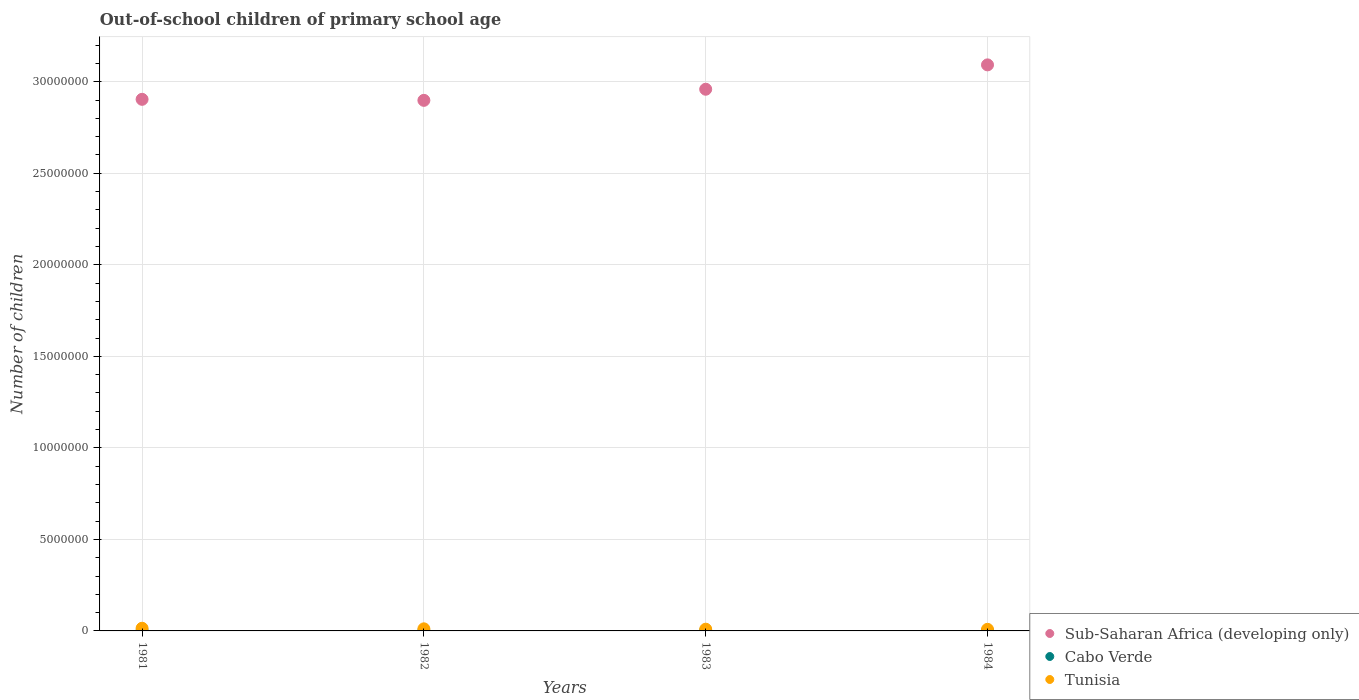How many different coloured dotlines are there?
Give a very brief answer. 3. Is the number of dotlines equal to the number of legend labels?
Ensure brevity in your answer.  Yes. What is the number of out-of-school children in Cabo Verde in 1982?
Offer a terse response. 6291. Across all years, what is the maximum number of out-of-school children in Tunisia?
Make the answer very short. 1.45e+05. Across all years, what is the minimum number of out-of-school children in Sub-Saharan Africa (developing only)?
Your response must be concise. 2.90e+07. In which year was the number of out-of-school children in Sub-Saharan Africa (developing only) minimum?
Provide a succinct answer. 1982. What is the total number of out-of-school children in Cabo Verde in the graph?
Provide a succinct answer. 2.58e+04. What is the difference between the number of out-of-school children in Cabo Verde in 1982 and that in 1984?
Your answer should be compact. 666. What is the difference between the number of out-of-school children in Cabo Verde in 1984 and the number of out-of-school children in Sub-Saharan Africa (developing only) in 1983?
Keep it short and to the point. -2.96e+07. What is the average number of out-of-school children in Sub-Saharan Africa (developing only) per year?
Your answer should be compact. 2.96e+07. In the year 1981, what is the difference between the number of out-of-school children in Sub-Saharan Africa (developing only) and number of out-of-school children in Tunisia?
Offer a very short reply. 2.89e+07. What is the ratio of the number of out-of-school children in Sub-Saharan Africa (developing only) in 1983 to that in 1984?
Your answer should be compact. 0.96. Is the number of out-of-school children in Sub-Saharan Africa (developing only) in 1983 less than that in 1984?
Provide a succinct answer. Yes. Is the difference between the number of out-of-school children in Sub-Saharan Africa (developing only) in 1981 and 1983 greater than the difference between the number of out-of-school children in Tunisia in 1981 and 1983?
Your response must be concise. No. What is the difference between the highest and the second highest number of out-of-school children in Tunisia?
Your response must be concise. 3.15e+04. What is the difference between the highest and the lowest number of out-of-school children in Cabo Verde?
Your response must be concise. 2586. Is the sum of the number of out-of-school children in Tunisia in 1982 and 1983 greater than the maximum number of out-of-school children in Sub-Saharan Africa (developing only) across all years?
Make the answer very short. No. Is it the case that in every year, the sum of the number of out-of-school children in Sub-Saharan Africa (developing only) and number of out-of-school children in Cabo Verde  is greater than the number of out-of-school children in Tunisia?
Keep it short and to the point. Yes. How many dotlines are there?
Your response must be concise. 3. How many years are there in the graph?
Make the answer very short. 4. What is the difference between two consecutive major ticks on the Y-axis?
Ensure brevity in your answer.  5.00e+06. Where does the legend appear in the graph?
Give a very brief answer. Bottom right. How are the legend labels stacked?
Provide a short and direct response. Vertical. What is the title of the graph?
Your answer should be very brief. Out-of-school children of primary school age. Does "Tuvalu" appear as one of the legend labels in the graph?
Your answer should be compact. No. What is the label or title of the X-axis?
Offer a terse response. Years. What is the label or title of the Y-axis?
Give a very brief answer. Number of children. What is the Number of children in Sub-Saharan Africa (developing only) in 1981?
Make the answer very short. 2.90e+07. What is the Number of children of Cabo Verde in 1981?
Keep it short and to the point. 5628. What is the Number of children of Tunisia in 1981?
Offer a very short reply. 1.45e+05. What is the Number of children of Sub-Saharan Africa (developing only) in 1982?
Your answer should be very brief. 2.90e+07. What is the Number of children of Cabo Verde in 1982?
Make the answer very short. 6291. What is the Number of children in Tunisia in 1982?
Give a very brief answer. 1.14e+05. What is the Number of children in Sub-Saharan Africa (developing only) in 1983?
Your response must be concise. 2.96e+07. What is the Number of children in Cabo Verde in 1983?
Provide a succinct answer. 8211. What is the Number of children in Tunisia in 1983?
Make the answer very short. 9.46e+04. What is the Number of children in Sub-Saharan Africa (developing only) in 1984?
Offer a terse response. 3.09e+07. What is the Number of children of Cabo Verde in 1984?
Keep it short and to the point. 5625. What is the Number of children of Tunisia in 1984?
Make the answer very short. 8.77e+04. Across all years, what is the maximum Number of children in Sub-Saharan Africa (developing only)?
Offer a terse response. 3.09e+07. Across all years, what is the maximum Number of children in Cabo Verde?
Provide a short and direct response. 8211. Across all years, what is the maximum Number of children in Tunisia?
Keep it short and to the point. 1.45e+05. Across all years, what is the minimum Number of children of Sub-Saharan Africa (developing only)?
Provide a short and direct response. 2.90e+07. Across all years, what is the minimum Number of children of Cabo Verde?
Give a very brief answer. 5625. Across all years, what is the minimum Number of children in Tunisia?
Give a very brief answer. 8.77e+04. What is the total Number of children in Sub-Saharan Africa (developing only) in the graph?
Keep it short and to the point. 1.19e+08. What is the total Number of children of Cabo Verde in the graph?
Provide a short and direct response. 2.58e+04. What is the total Number of children of Tunisia in the graph?
Provide a short and direct response. 4.42e+05. What is the difference between the Number of children of Sub-Saharan Africa (developing only) in 1981 and that in 1982?
Offer a terse response. 5.59e+04. What is the difference between the Number of children in Cabo Verde in 1981 and that in 1982?
Your answer should be very brief. -663. What is the difference between the Number of children of Tunisia in 1981 and that in 1982?
Ensure brevity in your answer.  3.15e+04. What is the difference between the Number of children of Sub-Saharan Africa (developing only) in 1981 and that in 1983?
Offer a very short reply. -5.51e+05. What is the difference between the Number of children of Cabo Verde in 1981 and that in 1983?
Give a very brief answer. -2583. What is the difference between the Number of children of Tunisia in 1981 and that in 1983?
Offer a very short reply. 5.08e+04. What is the difference between the Number of children of Sub-Saharan Africa (developing only) in 1981 and that in 1984?
Ensure brevity in your answer.  -1.88e+06. What is the difference between the Number of children of Cabo Verde in 1981 and that in 1984?
Make the answer very short. 3. What is the difference between the Number of children of Tunisia in 1981 and that in 1984?
Offer a very short reply. 5.78e+04. What is the difference between the Number of children of Sub-Saharan Africa (developing only) in 1982 and that in 1983?
Give a very brief answer. -6.07e+05. What is the difference between the Number of children of Cabo Verde in 1982 and that in 1983?
Ensure brevity in your answer.  -1920. What is the difference between the Number of children of Tunisia in 1982 and that in 1983?
Provide a short and direct response. 1.94e+04. What is the difference between the Number of children in Sub-Saharan Africa (developing only) in 1982 and that in 1984?
Offer a very short reply. -1.94e+06. What is the difference between the Number of children in Cabo Verde in 1982 and that in 1984?
Offer a terse response. 666. What is the difference between the Number of children of Tunisia in 1982 and that in 1984?
Your answer should be compact. 2.63e+04. What is the difference between the Number of children in Sub-Saharan Africa (developing only) in 1983 and that in 1984?
Give a very brief answer. -1.33e+06. What is the difference between the Number of children in Cabo Verde in 1983 and that in 1984?
Provide a succinct answer. 2586. What is the difference between the Number of children of Tunisia in 1983 and that in 1984?
Make the answer very short. 6971. What is the difference between the Number of children of Sub-Saharan Africa (developing only) in 1981 and the Number of children of Cabo Verde in 1982?
Offer a very short reply. 2.90e+07. What is the difference between the Number of children of Sub-Saharan Africa (developing only) in 1981 and the Number of children of Tunisia in 1982?
Offer a very short reply. 2.89e+07. What is the difference between the Number of children of Cabo Verde in 1981 and the Number of children of Tunisia in 1982?
Make the answer very short. -1.08e+05. What is the difference between the Number of children of Sub-Saharan Africa (developing only) in 1981 and the Number of children of Cabo Verde in 1983?
Keep it short and to the point. 2.90e+07. What is the difference between the Number of children of Sub-Saharan Africa (developing only) in 1981 and the Number of children of Tunisia in 1983?
Offer a terse response. 2.89e+07. What is the difference between the Number of children of Cabo Verde in 1981 and the Number of children of Tunisia in 1983?
Ensure brevity in your answer.  -8.90e+04. What is the difference between the Number of children in Sub-Saharan Africa (developing only) in 1981 and the Number of children in Cabo Verde in 1984?
Provide a short and direct response. 2.90e+07. What is the difference between the Number of children in Sub-Saharan Africa (developing only) in 1981 and the Number of children in Tunisia in 1984?
Provide a succinct answer. 2.90e+07. What is the difference between the Number of children in Cabo Verde in 1981 and the Number of children in Tunisia in 1984?
Your answer should be very brief. -8.20e+04. What is the difference between the Number of children in Sub-Saharan Africa (developing only) in 1982 and the Number of children in Cabo Verde in 1983?
Offer a terse response. 2.90e+07. What is the difference between the Number of children in Sub-Saharan Africa (developing only) in 1982 and the Number of children in Tunisia in 1983?
Make the answer very short. 2.89e+07. What is the difference between the Number of children of Cabo Verde in 1982 and the Number of children of Tunisia in 1983?
Your answer should be compact. -8.84e+04. What is the difference between the Number of children of Sub-Saharan Africa (developing only) in 1982 and the Number of children of Cabo Verde in 1984?
Keep it short and to the point. 2.90e+07. What is the difference between the Number of children of Sub-Saharan Africa (developing only) in 1982 and the Number of children of Tunisia in 1984?
Provide a short and direct response. 2.89e+07. What is the difference between the Number of children in Cabo Verde in 1982 and the Number of children in Tunisia in 1984?
Keep it short and to the point. -8.14e+04. What is the difference between the Number of children in Sub-Saharan Africa (developing only) in 1983 and the Number of children in Cabo Verde in 1984?
Ensure brevity in your answer.  2.96e+07. What is the difference between the Number of children of Sub-Saharan Africa (developing only) in 1983 and the Number of children of Tunisia in 1984?
Your answer should be compact. 2.95e+07. What is the difference between the Number of children in Cabo Verde in 1983 and the Number of children in Tunisia in 1984?
Ensure brevity in your answer.  -7.95e+04. What is the average Number of children of Sub-Saharan Africa (developing only) per year?
Ensure brevity in your answer.  2.96e+07. What is the average Number of children of Cabo Verde per year?
Your answer should be compact. 6438.75. What is the average Number of children of Tunisia per year?
Your answer should be very brief. 1.10e+05. In the year 1981, what is the difference between the Number of children of Sub-Saharan Africa (developing only) and Number of children of Cabo Verde?
Provide a succinct answer. 2.90e+07. In the year 1981, what is the difference between the Number of children in Sub-Saharan Africa (developing only) and Number of children in Tunisia?
Give a very brief answer. 2.89e+07. In the year 1981, what is the difference between the Number of children of Cabo Verde and Number of children of Tunisia?
Provide a short and direct response. -1.40e+05. In the year 1982, what is the difference between the Number of children of Sub-Saharan Africa (developing only) and Number of children of Cabo Verde?
Give a very brief answer. 2.90e+07. In the year 1982, what is the difference between the Number of children of Sub-Saharan Africa (developing only) and Number of children of Tunisia?
Give a very brief answer. 2.89e+07. In the year 1982, what is the difference between the Number of children of Cabo Verde and Number of children of Tunisia?
Give a very brief answer. -1.08e+05. In the year 1983, what is the difference between the Number of children of Sub-Saharan Africa (developing only) and Number of children of Cabo Verde?
Offer a terse response. 2.96e+07. In the year 1983, what is the difference between the Number of children in Sub-Saharan Africa (developing only) and Number of children in Tunisia?
Offer a terse response. 2.95e+07. In the year 1983, what is the difference between the Number of children in Cabo Verde and Number of children in Tunisia?
Your answer should be compact. -8.64e+04. In the year 1984, what is the difference between the Number of children in Sub-Saharan Africa (developing only) and Number of children in Cabo Verde?
Offer a terse response. 3.09e+07. In the year 1984, what is the difference between the Number of children in Sub-Saharan Africa (developing only) and Number of children in Tunisia?
Keep it short and to the point. 3.08e+07. In the year 1984, what is the difference between the Number of children of Cabo Verde and Number of children of Tunisia?
Provide a short and direct response. -8.20e+04. What is the ratio of the Number of children in Sub-Saharan Africa (developing only) in 1981 to that in 1982?
Your answer should be compact. 1. What is the ratio of the Number of children of Cabo Verde in 1981 to that in 1982?
Keep it short and to the point. 0.89. What is the ratio of the Number of children of Tunisia in 1981 to that in 1982?
Your answer should be compact. 1.28. What is the ratio of the Number of children of Sub-Saharan Africa (developing only) in 1981 to that in 1983?
Ensure brevity in your answer.  0.98. What is the ratio of the Number of children in Cabo Verde in 1981 to that in 1983?
Provide a succinct answer. 0.69. What is the ratio of the Number of children of Tunisia in 1981 to that in 1983?
Ensure brevity in your answer.  1.54. What is the ratio of the Number of children of Sub-Saharan Africa (developing only) in 1981 to that in 1984?
Make the answer very short. 0.94. What is the ratio of the Number of children of Tunisia in 1981 to that in 1984?
Ensure brevity in your answer.  1.66. What is the ratio of the Number of children of Sub-Saharan Africa (developing only) in 1982 to that in 1983?
Provide a succinct answer. 0.98. What is the ratio of the Number of children of Cabo Verde in 1982 to that in 1983?
Your answer should be compact. 0.77. What is the ratio of the Number of children of Tunisia in 1982 to that in 1983?
Your response must be concise. 1.2. What is the ratio of the Number of children of Sub-Saharan Africa (developing only) in 1982 to that in 1984?
Offer a terse response. 0.94. What is the ratio of the Number of children in Cabo Verde in 1982 to that in 1984?
Your answer should be compact. 1.12. What is the ratio of the Number of children of Tunisia in 1982 to that in 1984?
Provide a short and direct response. 1.3. What is the ratio of the Number of children in Sub-Saharan Africa (developing only) in 1983 to that in 1984?
Offer a very short reply. 0.96. What is the ratio of the Number of children of Cabo Verde in 1983 to that in 1984?
Keep it short and to the point. 1.46. What is the ratio of the Number of children of Tunisia in 1983 to that in 1984?
Give a very brief answer. 1.08. What is the difference between the highest and the second highest Number of children in Sub-Saharan Africa (developing only)?
Make the answer very short. 1.33e+06. What is the difference between the highest and the second highest Number of children in Cabo Verde?
Offer a very short reply. 1920. What is the difference between the highest and the second highest Number of children of Tunisia?
Your answer should be very brief. 3.15e+04. What is the difference between the highest and the lowest Number of children in Sub-Saharan Africa (developing only)?
Give a very brief answer. 1.94e+06. What is the difference between the highest and the lowest Number of children in Cabo Verde?
Your answer should be very brief. 2586. What is the difference between the highest and the lowest Number of children in Tunisia?
Your answer should be very brief. 5.78e+04. 